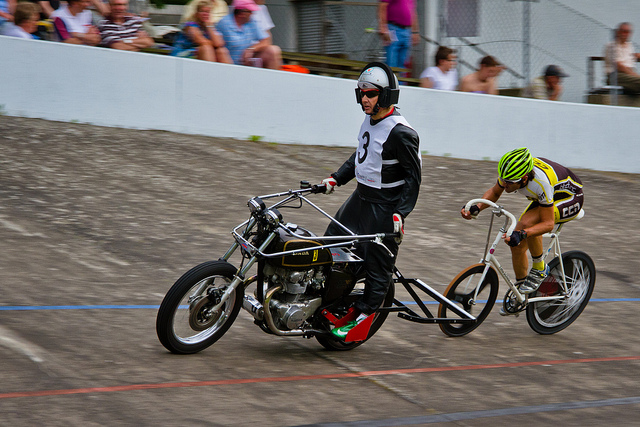Extract all visible text content from this image. 3 